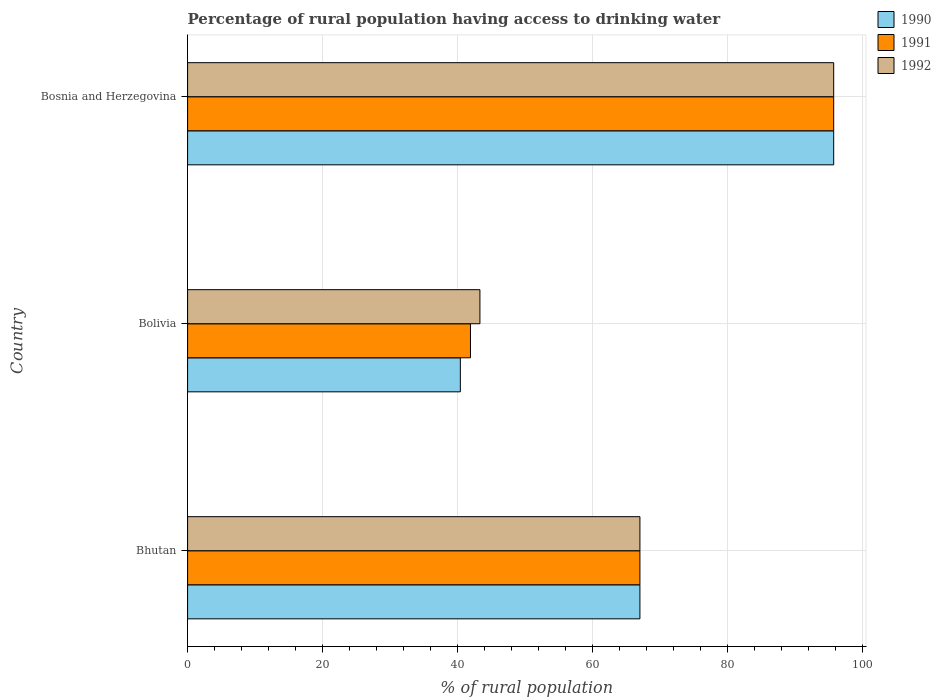Are the number of bars on each tick of the Y-axis equal?
Give a very brief answer. Yes. How many bars are there on the 1st tick from the top?
Ensure brevity in your answer.  3. How many bars are there on the 1st tick from the bottom?
Offer a very short reply. 3. What is the label of the 3rd group of bars from the top?
Provide a succinct answer. Bhutan. In how many cases, is the number of bars for a given country not equal to the number of legend labels?
Make the answer very short. 0. Across all countries, what is the maximum percentage of rural population having access to drinking water in 1990?
Give a very brief answer. 95.7. Across all countries, what is the minimum percentage of rural population having access to drinking water in 1991?
Ensure brevity in your answer.  41.9. In which country was the percentage of rural population having access to drinking water in 1990 maximum?
Ensure brevity in your answer.  Bosnia and Herzegovina. In which country was the percentage of rural population having access to drinking water in 1991 minimum?
Make the answer very short. Bolivia. What is the total percentage of rural population having access to drinking water in 1990 in the graph?
Your response must be concise. 203.1. What is the difference between the percentage of rural population having access to drinking water in 1990 in Bhutan and that in Bolivia?
Provide a succinct answer. 26.6. What is the difference between the percentage of rural population having access to drinking water in 1991 in Bolivia and the percentage of rural population having access to drinking water in 1990 in Bosnia and Herzegovina?
Ensure brevity in your answer.  -53.8. What is the average percentage of rural population having access to drinking water in 1992 per country?
Your response must be concise. 68.67. What is the difference between the percentage of rural population having access to drinking water in 1991 and percentage of rural population having access to drinking water in 1990 in Bhutan?
Offer a terse response. 0. What is the ratio of the percentage of rural population having access to drinking water in 1990 in Bhutan to that in Bolivia?
Offer a terse response. 1.66. What is the difference between the highest and the second highest percentage of rural population having access to drinking water in 1991?
Give a very brief answer. 28.7. What is the difference between the highest and the lowest percentage of rural population having access to drinking water in 1990?
Provide a short and direct response. 55.3. What does the 1st bar from the top in Bolivia represents?
Give a very brief answer. 1992. What does the 3rd bar from the bottom in Bolivia represents?
Ensure brevity in your answer.  1992. How many bars are there?
Your response must be concise. 9. How many countries are there in the graph?
Ensure brevity in your answer.  3. Are the values on the major ticks of X-axis written in scientific E-notation?
Your answer should be compact. No. Does the graph contain grids?
Keep it short and to the point. Yes. Where does the legend appear in the graph?
Keep it short and to the point. Top right. How many legend labels are there?
Offer a very short reply. 3. How are the legend labels stacked?
Your answer should be very brief. Vertical. What is the title of the graph?
Offer a very short reply. Percentage of rural population having access to drinking water. What is the label or title of the X-axis?
Provide a short and direct response. % of rural population. What is the % of rural population in 1990 in Bhutan?
Your answer should be compact. 67. What is the % of rural population in 1992 in Bhutan?
Your answer should be compact. 67. What is the % of rural population in 1990 in Bolivia?
Give a very brief answer. 40.4. What is the % of rural population of 1991 in Bolivia?
Offer a very short reply. 41.9. What is the % of rural population of 1992 in Bolivia?
Offer a very short reply. 43.3. What is the % of rural population in 1990 in Bosnia and Herzegovina?
Provide a short and direct response. 95.7. What is the % of rural population of 1991 in Bosnia and Herzegovina?
Ensure brevity in your answer.  95.7. What is the % of rural population in 1992 in Bosnia and Herzegovina?
Provide a short and direct response. 95.7. Across all countries, what is the maximum % of rural population of 1990?
Your answer should be very brief. 95.7. Across all countries, what is the maximum % of rural population in 1991?
Ensure brevity in your answer.  95.7. Across all countries, what is the maximum % of rural population of 1992?
Offer a very short reply. 95.7. Across all countries, what is the minimum % of rural population in 1990?
Offer a very short reply. 40.4. Across all countries, what is the minimum % of rural population in 1991?
Make the answer very short. 41.9. Across all countries, what is the minimum % of rural population in 1992?
Provide a succinct answer. 43.3. What is the total % of rural population of 1990 in the graph?
Provide a short and direct response. 203.1. What is the total % of rural population in 1991 in the graph?
Offer a very short reply. 204.6. What is the total % of rural population in 1992 in the graph?
Make the answer very short. 206. What is the difference between the % of rural population in 1990 in Bhutan and that in Bolivia?
Offer a terse response. 26.6. What is the difference between the % of rural population in 1991 in Bhutan and that in Bolivia?
Provide a succinct answer. 25.1. What is the difference between the % of rural population in 1992 in Bhutan and that in Bolivia?
Make the answer very short. 23.7. What is the difference between the % of rural population in 1990 in Bhutan and that in Bosnia and Herzegovina?
Offer a terse response. -28.7. What is the difference between the % of rural population of 1991 in Bhutan and that in Bosnia and Herzegovina?
Ensure brevity in your answer.  -28.7. What is the difference between the % of rural population of 1992 in Bhutan and that in Bosnia and Herzegovina?
Offer a terse response. -28.7. What is the difference between the % of rural population in 1990 in Bolivia and that in Bosnia and Herzegovina?
Give a very brief answer. -55.3. What is the difference between the % of rural population of 1991 in Bolivia and that in Bosnia and Herzegovina?
Your answer should be compact. -53.8. What is the difference between the % of rural population of 1992 in Bolivia and that in Bosnia and Herzegovina?
Make the answer very short. -52.4. What is the difference between the % of rural population in 1990 in Bhutan and the % of rural population in 1991 in Bolivia?
Provide a succinct answer. 25.1. What is the difference between the % of rural population of 1990 in Bhutan and the % of rural population of 1992 in Bolivia?
Provide a succinct answer. 23.7. What is the difference between the % of rural population of 1991 in Bhutan and the % of rural population of 1992 in Bolivia?
Make the answer very short. 23.7. What is the difference between the % of rural population in 1990 in Bhutan and the % of rural population in 1991 in Bosnia and Herzegovina?
Give a very brief answer. -28.7. What is the difference between the % of rural population of 1990 in Bhutan and the % of rural population of 1992 in Bosnia and Herzegovina?
Offer a terse response. -28.7. What is the difference between the % of rural population of 1991 in Bhutan and the % of rural population of 1992 in Bosnia and Herzegovina?
Your answer should be compact. -28.7. What is the difference between the % of rural population of 1990 in Bolivia and the % of rural population of 1991 in Bosnia and Herzegovina?
Offer a very short reply. -55.3. What is the difference between the % of rural population of 1990 in Bolivia and the % of rural population of 1992 in Bosnia and Herzegovina?
Your answer should be compact. -55.3. What is the difference between the % of rural population of 1991 in Bolivia and the % of rural population of 1992 in Bosnia and Herzegovina?
Keep it short and to the point. -53.8. What is the average % of rural population in 1990 per country?
Offer a very short reply. 67.7. What is the average % of rural population in 1991 per country?
Provide a succinct answer. 68.2. What is the average % of rural population of 1992 per country?
Offer a terse response. 68.67. What is the difference between the % of rural population in 1990 and % of rural population in 1992 in Bhutan?
Your response must be concise. 0. What is the difference between the % of rural population of 1990 and % of rural population of 1991 in Bolivia?
Provide a succinct answer. -1.5. What is the difference between the % of rural population in 1990 and % of rural population in 1992 in Bosnia and Herzegovina?
Make the answer very short. 0. What is the ratio of the % of rural population in 1990 in Bhutan to that in Bolivia?
Your answer should be very brief. 1.66. What is the ratio of the % of rural population in 1991 in Bhutan to that in Bolivia?
Your answer should be compact. 1.6. What is the ratio of the % of rural population in 1992 in Bhutan to that in Bolivia?
Provide a short and direct response. 1.55. What is the ratio of the % of rural population of 1990 in Bhutan to that in Bosnia and Herzegovina?
Ensure brevity in your answer.  0.7. What is the ratio of the % of rural population in 1991 in Bhutan to that in Bosnia and Herzegovina?
Your answer should be compact. 0.7. What is the ratio of the % of rural population in 1992 in Bhutan to that in Bosnia and Herzegovina?
Your answer should be compact. 0.7. What is the ratio of the % of rural population in 1990 in Bolivia to that in Bosnia and Herzegovina?
Offer a terse response. 0.42. What is the ratio of the % of rural population of 1991 in Bolivia to that in Bosnia and Herzegovina?
Give a very brief answer. 0.44. What is the ratio of the % of rural population in 1992 in Bolivia to that in Bosnia and Herzegovina?
Provide a succinct answer. 0.45. What is the difference between the highest and the second highest % of rural population in 1990?
Ensure brevity in your answer.  28.7. What is the difference between the highest and the second highest % of rural population in 1991?
Offer a terse response. 28.7. What is the difference between the highest and the second highest % of rural population of 1992?
Your answer should be very brief. 28.7. What is the difference between the highest and the lowest % of rural population of 1990?
Your response must be concise. 55.3. What is the difference between the highest and the lowest % of rural population in 1991?
Your answer should be compact. 53.8. What is the difference between the highest and the lowest % of rural population in 1992?
Your response must be concise. 52.4. 